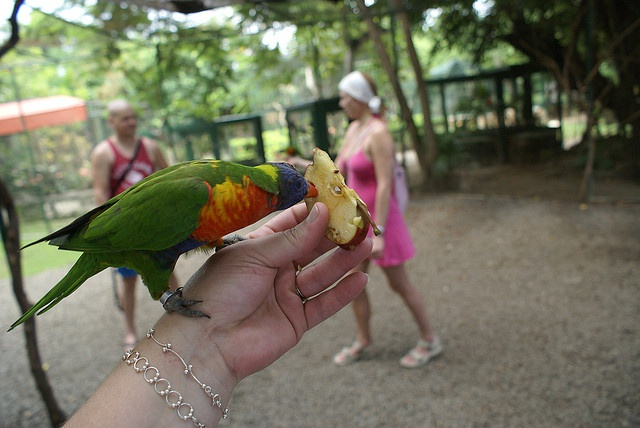Describe the objects in this image and their specific colors. I can see people in white, brown, gray, darkgray, and maroon tones, bird in white, black, darkgreen, and maroon tones, people in white, gray, and darkgray tones, people in white, gray, and darkgray tones, and apple in white, tan, maroon, and olive tones in this image. 